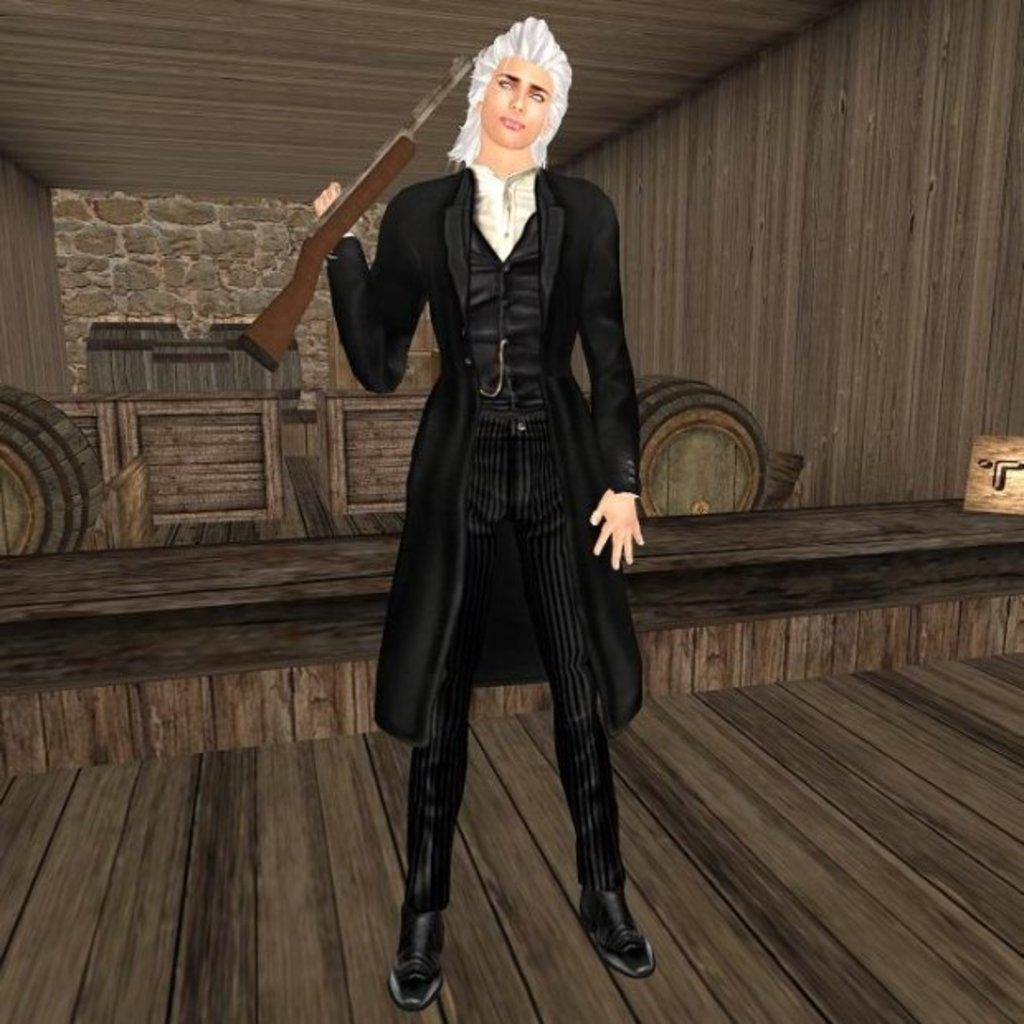Who or what is present in the image? There is a person in the image. What is the person doing in the image? The person is standing on the floor and holding a gun. What other objects can be seen in the image? There are drums visible in the image. What type of wall is present in the image? There is a wooden wall in the image. What type of cheese is being used to hold the tent in the image? There is no cheese or tent present in the image. 